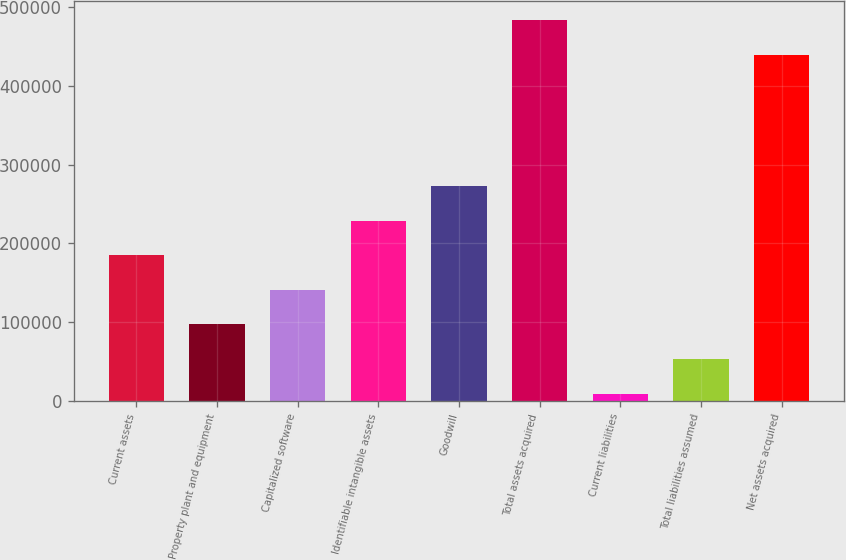Convert chart to OTSL. <chart><loc_0><loc_0><loc_500><loc_500><bar_chart><fcel>Current assets<fcel>Property plant and equipment<fcel>Capitalized software<fcel>Identifiable intangible assets<fcel>Goodwill<fcel>Total assets acquired<fcel>Current liabilities<fcel>Total liabilities assumed<fcel>Net assets acquired<nl><fcel>185036<fcel>97180.4<fcel>141108<fcel>228964<fcel>272891<fcel>483205<fcel>9325<fcel>53252.7<fcel>439277<nl></chart> 